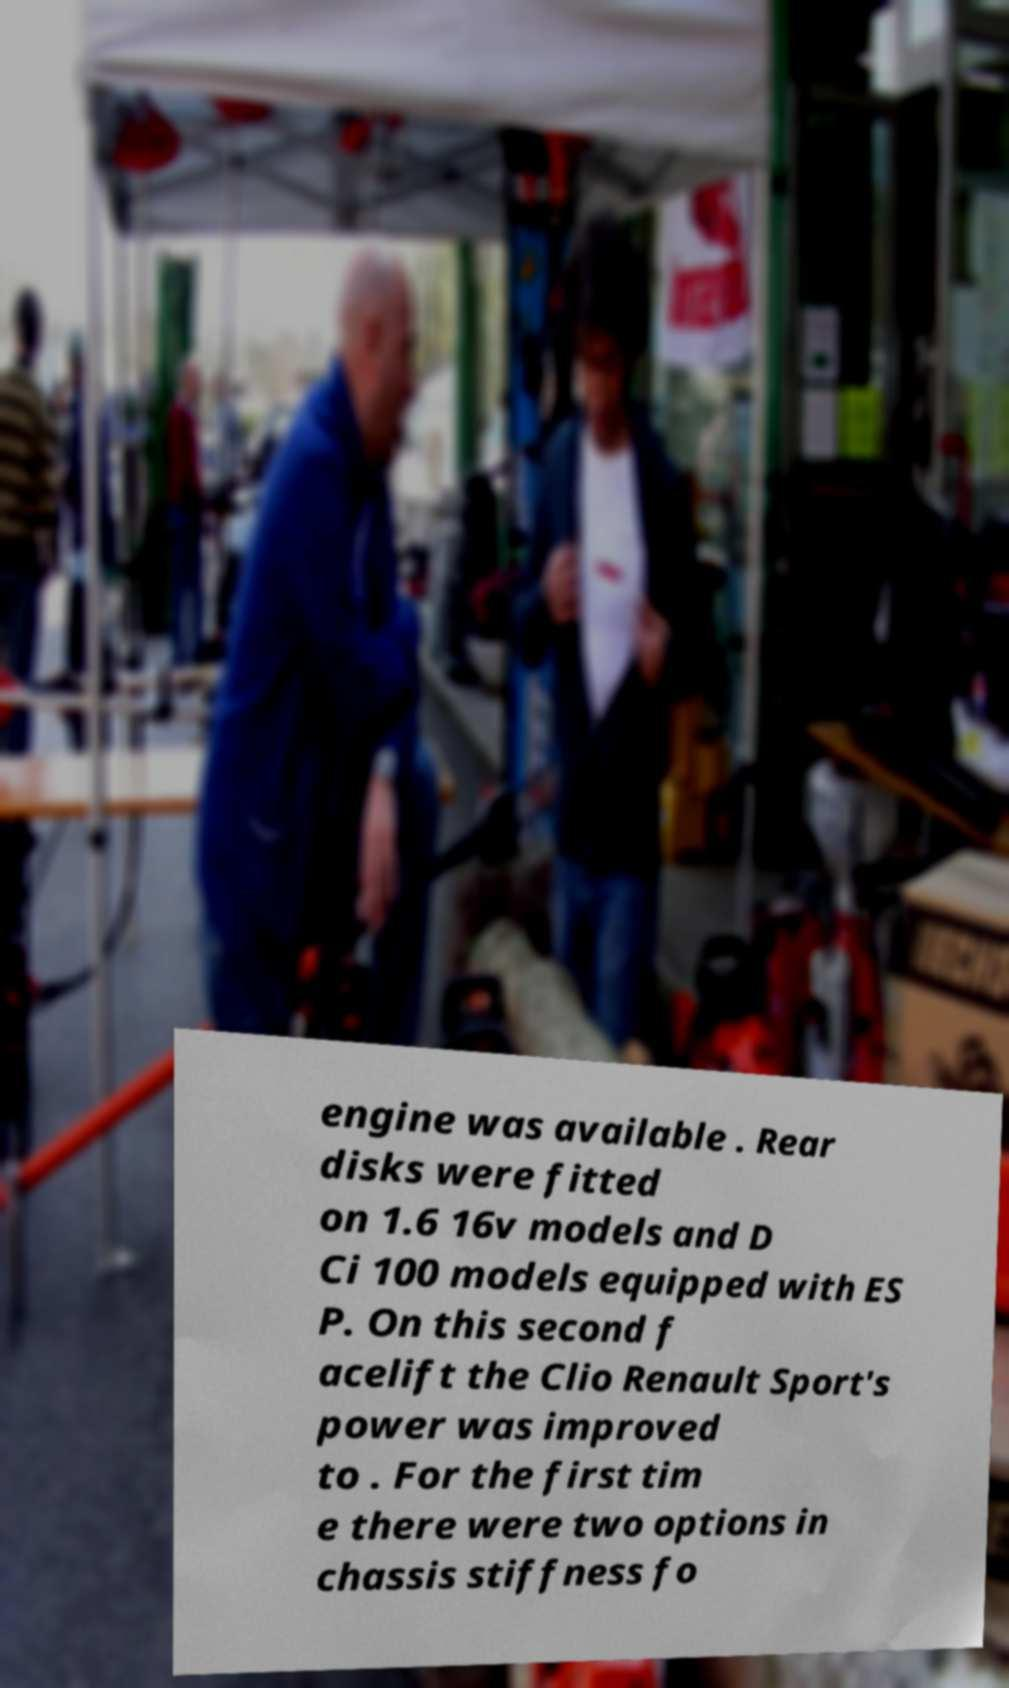For documentation purposes, I need the text within this image transcribed. Could you provide that? engine was available . Rear disks were fitted on 1.6 16v models and D Ci 100 models equipped with ES P. On this second f acelift the Clio Renault Sport's power was improved to . For the first tim e there were two options in chassis stiffness fo 